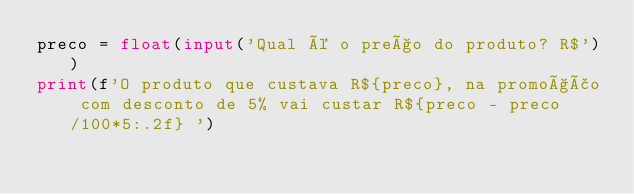<code> <loc_0><loc_0><loc_500><loc_500><_Python_>preco = float(input('Qual é o preço do produto? R$'))
print(f'O produto que custava R${preco}, na promoção com desconto de 5% vai custar R${preco - preco/100*5:.2f} ')
</code> 